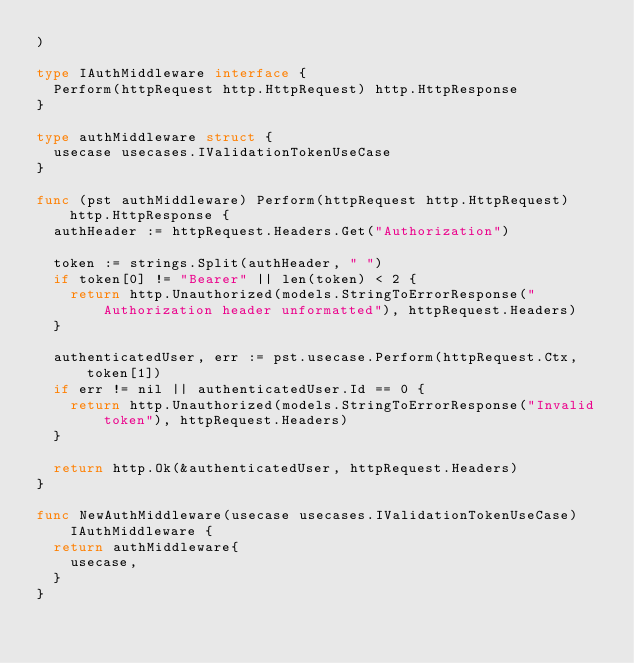Convert code to text. <code><loc_0><loc_0><loc_500><loc_500><_Go_>)

type IAuthMiddleware interface {
	Perform(httpRequest http.HttpRequest) http.HttpResponse
}

type authMiddleware struct {
	usecase usecases.IValidationTokenUseCase
}

func (pst authMiddleware) Perform(httpRequest http.HttpRequest) http.HttpResponse {
	authHeader := httpRequest.Headers.Get("Authorization")

	token := strings.Split(authHeader, " ")
	if token[0] != "Bearer" || len(token) < 2 {
		return http.Unauthorized(models.StringToErrorResponse("Authorization header unformatted"), httpRequest.Headers)
	}

	authenticatedUser, err := pst.usecase.Perform(httpRequest.Ctx, token[1])
	if err != nil || authenticatedUser.Id == 0 {
		return http.Unauthorized(models.StringToErrorResponse("Invalid token"), httpRequest.Headers)
	}

	return http.Ok(&authenticatedUser, httpRequest.Headers)
}

func NewAuthMiddleware(usecase usecases.IValidationTokenUseCase) IAuthMiddleware {
	return authMiddleware{
		usecase,
	}
}
</code> 